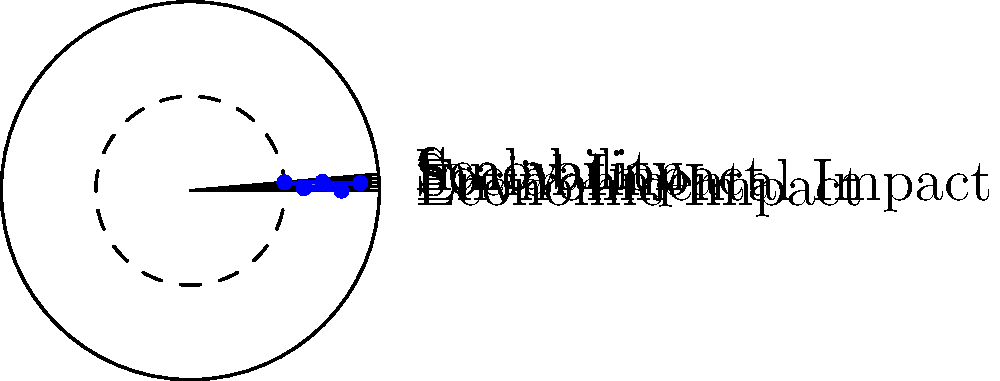Given the radar chart representing various factors of a scientific project, calculate the overall social impact score. Assume that the social impact score is the average of all factors, where each factor's maximum value is 1.0. Round your answer to two decimal places. To calculate the overall social impact score, we need to follow these steps:

1. Identify the values for each factor from the radar chart:
   - Economic Impact: 0.8
   - Environmental Impact: 0.6
   - Social Impact: 0.9
   - Scalability: 0.7
   - Innovation: 0.5

2. Calculate the sum of all factor values:
   $$ 0.8 + 0.6 + 0.9 + 0.7 + 0.5 = 3.5 $$

3. Count the number of factors:
   There are 5 factors in total.

4. Calculate the average by dividing the sum by the number of factors:
   $$ \text{Average} = \frac{\text{Sum of factors}}{\text{Number of factors}} = \frac{3.5}{5} = 0.7 $$

5. Round the result to two decimal places:
   The result is already rounded to two decimal places, so no further rounding is necessary.

Therefore, the overall social impact score is 0.70.
Answer: 0.70 